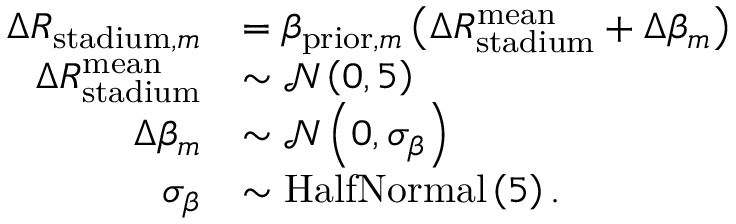<formula> <loc_0><loc_0><loc_500><loc_500>\begin{array} { r l } { \Delta R _ { s t a d i u m , m } } & { = \beta _ { p r i o r , m } \left ( \Delta R _ { s t a d i u m } ^ { m e a n } + \Delta \beta _ { m } \right ) } \\ { \Delta R _ { s t a d i u m } ^ { m e a n } } & { \sim \mathcal { N } \left ( 0 , 5 \right ) } \\ { \Delta \beta _ { m } } & { \sim \mathcal { N } \left ( 0 , \sigma _ { \beta } \right ) } \\ { \sigma _ { \beta } } & { \sim H a l f N o r m a l \left ( 5 \right ) . } \end{array}</formula> 